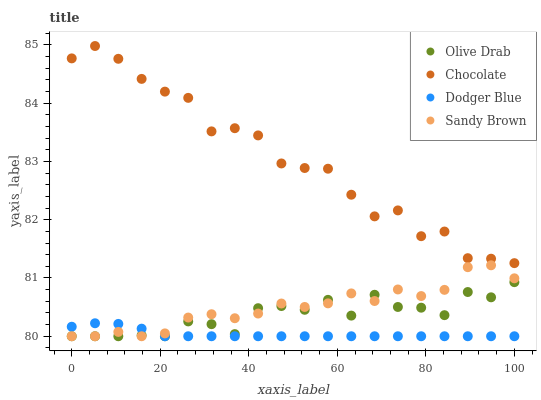Does Dodger Blue have the minimum area under the curve?
Answer yes or no. Yes. Does Chocolate have the maximum area under the curve?
Answer yes or no. Yes. Does Olive Drab have the minimum area under the curve?
Answer yes or no. No. Does Olive Drab have the maximum area under the curve?
Answer yes or no. No. Is Dodger Blue the smoothest?
Answer yes or no. Yes. Is Chocolate the roughest?
Answer yes or no. Yes. Is Olive Drab the smoothest?
Answer yes or no. No. Is Olive Drab the roughest?
Answer yes or no. No. Does Sandy Brown have the lowest value?
Answer yes or no. Yes. Does Chocolate have the lowest value?
Answer yes or no. No. Does Chocolate have the highest value?
Answer yes or no. Yes. Does Olive Drab have the highest value?
Answer yes or no. No. Is Dodger Blue less than Chocolate?
Answer yes or no. Yes. Is Chocolate greater than Dodger Blue?
Answer yes or no. Yes. Does Dodger Blue intersect Olive Drab?
Answer yes or no. Yes. Is Dodger Blue less than Olive Drab?
Answer yes or no. No. Is Dodger Blue greater than Olive Drab?
Answer yes or no. No. Does Dodger Blue intersect Chocolate?
Answer yes or no. No. 